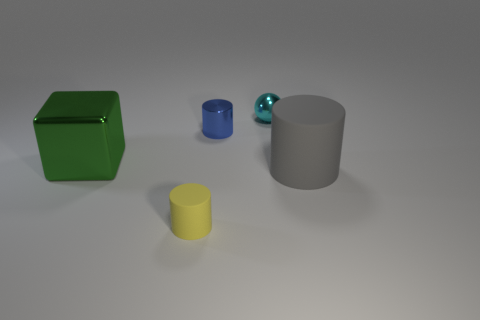What number of metal objects are both to the right of the green block and in front of the cyan metal thing?
Make the answer very short. 1. There is a shiny object that is the same size as the cyan shiny ball; what is its shape?
Give a very brief answer. Cylinder. How big is the yellow cylinder?
Give a very brief answer. Small. There is a tiny cylinder that is right of the matte thing that is to the left of the tiny metal object in front of the small cyan object; what is its material?
Keep it short and to the point. Metal. There is a big object that is made of the same material as the small cyan thing; what is its color?
Keep it short and to the point. Green. What number of matte things are right of the tiny object in front of the large thing on the left side of the big cylinder?
Make the answer very short. 1. Is there any other thing that has the same shape as the large metallic object?
Offer a very short reply. No. What number of things are metal things that are on the left side of the sphere or green things?
Offer a terse response. 2. There is a matte thing to the left of the cyan ball; is its color the same as the ball?
Offer a very short reply. No. What shape is the thing on the left side of the object that is in front of the gray cylinder?
Your answer should be compact. Cube. 